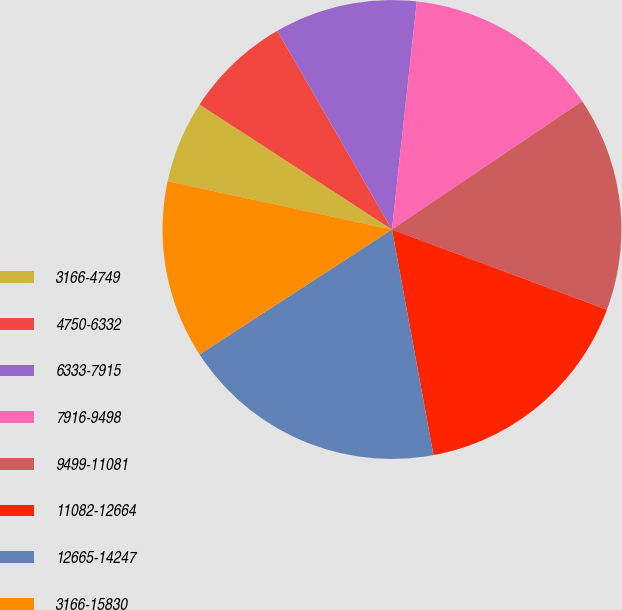Convert chart. <chart><loc_0><loc_0><loc_500><loc_500><pie_chart><fcel>3166-4749<fcel>4750-6332<fcel>6333-7915<fcel>7916-9498<fcel>9499-11081<fcel>11082-12664<fcel>12665-14247<fcel>3166-15830<nl><fcel>5.8%<fcel>7.5%<fcel>10.06%<fcel>13.83%<fcel>15.13%<fcel>16.42%<fcel>18.73%<fcel>12.54%<nl></chart> 